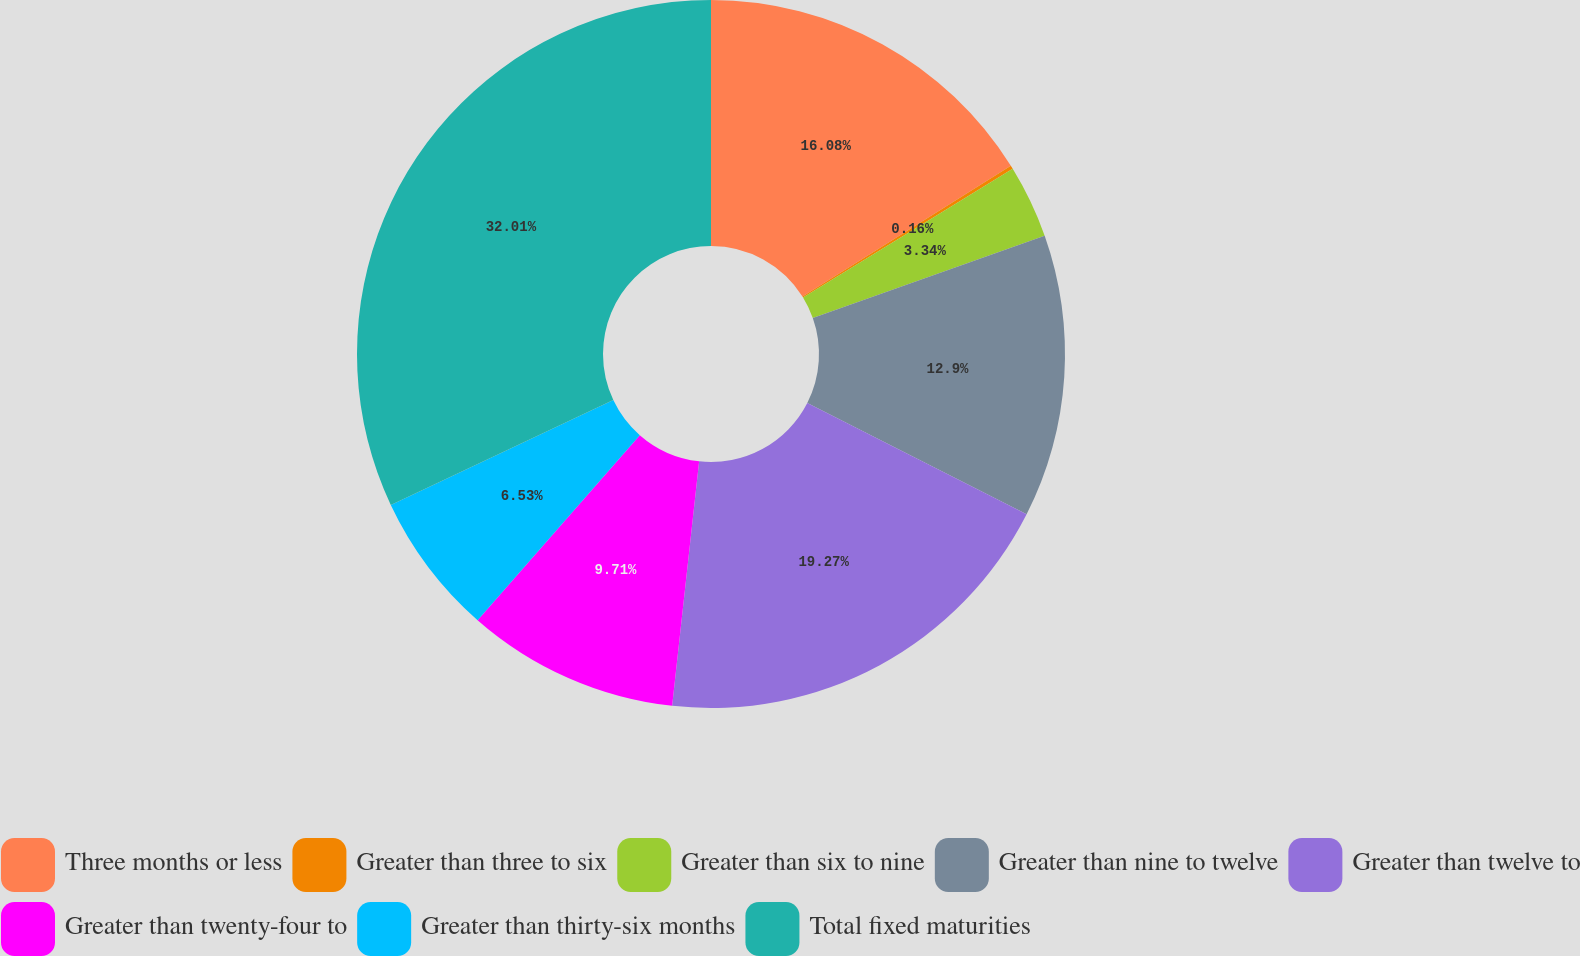Convert chart to OTSL. <chart><loc_0><loc_0><loc_500><loc_500><pie_chart><fcel>Three months or less<fcel>Greater than three to six<fcel>Greater than six to nine<fcel>Greater than nine to twelve<fcel>Greater than twelve to<fcel>Greater than twenty-four to<fcel>Greater than thirty-six months<fcel>Total fixed maturities<nl><fcel>16.08%<fcel>0.16%<fcel>3.34%<fcel>12.9%<fcel>19.27%<fcel>9.71%<fcel>6.53%<fcel>32.01%<nl></chart> 